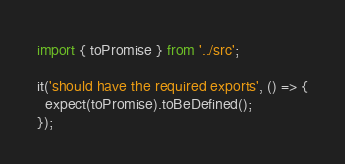Convert code to text. <code><loc_0><loc_0><loc_500><loc_500><_TypeScript_>import { toPromise } from '../src';

it('should have the required exports', () => {
  expect(toPromise).toBeDefined();
});
</code> 